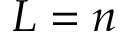<formula> <loc_0><loc_0><loc_500><loc_500>L = n</formula> 